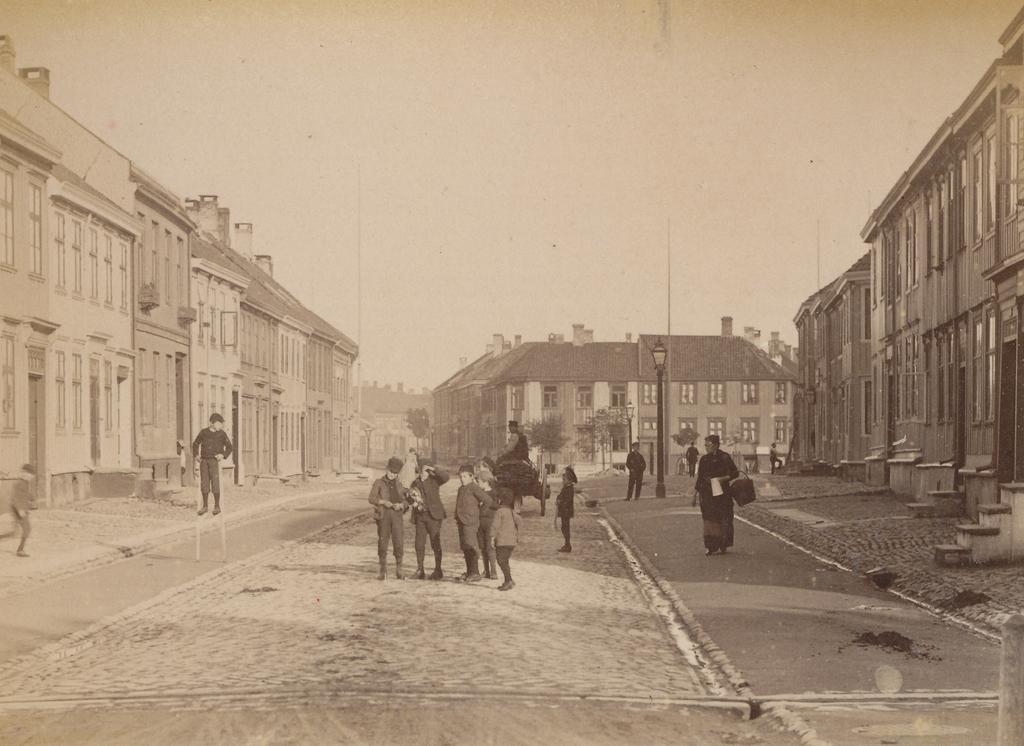Describe this image in one or two sentences. This is a black and white image. In this image we can see persons standing on the road and one of them is sitting on the animal. In the background there are buildings, street poles, street lights, trees and sky. 